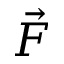<formula> <loc_0><loc_0><loc_500><loc_500>\vec { F }</formula> 